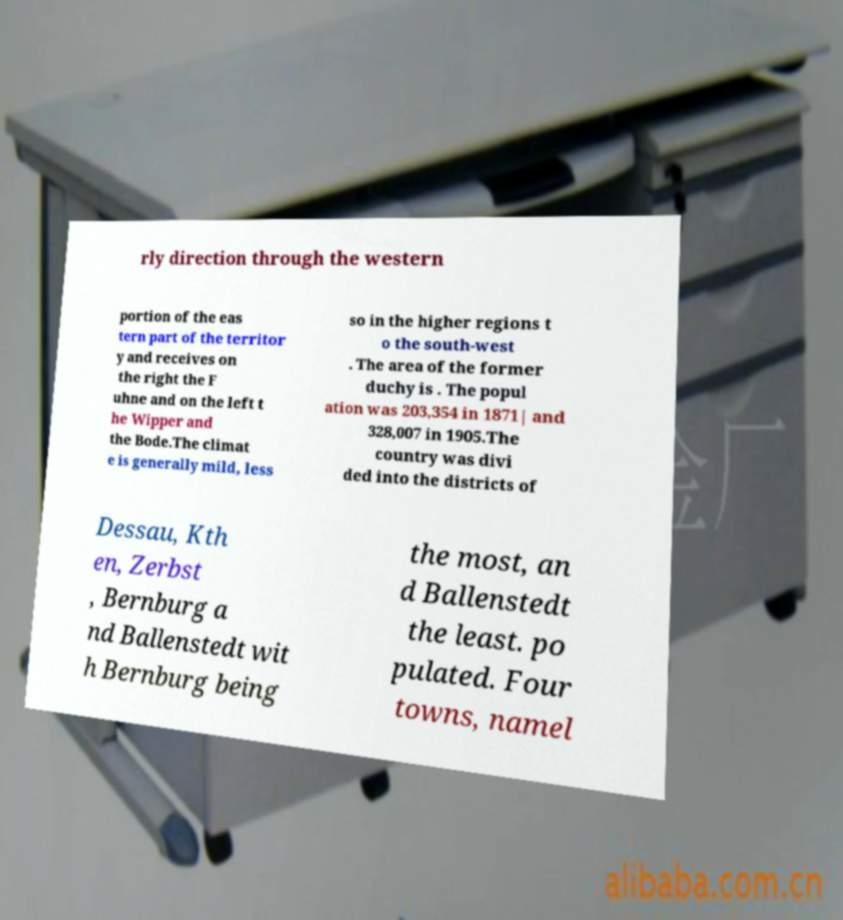What messages or text are displayed in this image? I need them in a readable, typed format. rly direction through the western portion of the eas tern part of the territor y and receives on the right the F uhne and on the left t he Wipper and the Bode.The climat e is generally mild, less so in the higher regions t o the south-west . The area of the former duchy is . The popul ation was 203,354 in 1871| and 328,007 in 1905.The country was divi ded into the districts of Dessau, Kth en, Zerbst , Bernburg a nd Ballenstedt wit h Bernburg being the most, an d Ballenstedt the least. po pulated. Four towns, namel 